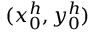Convert formula to latex. <formula><loc_0><loc_0><loc_500><loc_500>( x _ { 0 } ^ { h } , y _ { 0 } ^ { h } )</formula> 